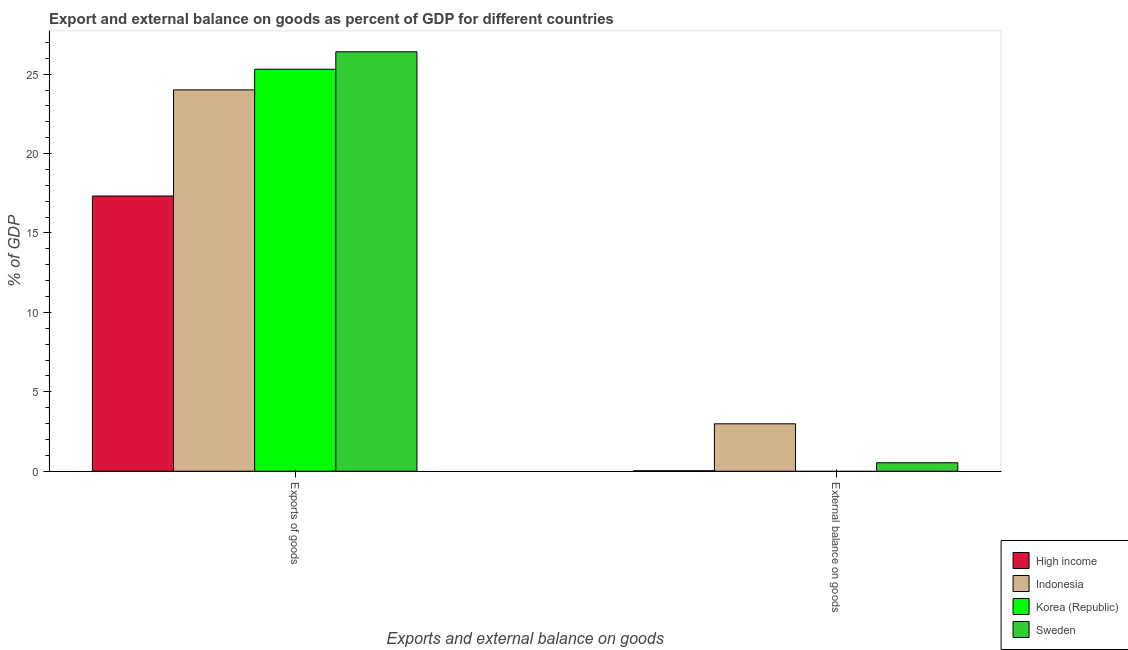Are the number of bars per tick equal to the number of legend labels?
Your response must be concise. No. Are the number of bars on each tick of the X-axis equal?
Your response must be concise. No. How many bars are there on the 1st tick from the left?
Your response must be concise. 4. What is the label of the 2nd group of bars from the left?
Provide a short and direct response. External balance on goods. What is the export of goods as percentage of gdp in Sweden?
Your answer should be compact. 26.41. Across all countries, what is the maximum external balance on goods as percentage of gdp?
Offer a terse response. 2.99. Across all countries, what is the minimum export of goods as percentage of gdp?
Keep it short and to the point. 17.33. What is the total external balance on goods as percentage of gdp in the graph?
Your answer should be very brief. 3.55. What is the difference between the export of goods as percentage of gdp in Korea (Republic) and that in Sweden?
Provide a succinct answer. -1.1. What is the difference between the external balance on goods as percentage of gdp in Sweden and the export of goods as percentage of gdp in High income?
Your answer should be very brief. -16.79. What is the average export of goods as percentage of gdp per country?
Ensure brevity in your answer.  23.26. What is the difference between the external balance on goods as percentage of gdp and export of goods as percentage of gdp in Indonesia?
Keep it short and to the point. -21.02. What is the ratio of the export of goods as percentage of gdp in Korea (Republic) to that in High income?
Your response must be concise. 1.46. In how many countries, is the external balance on goods as percentage of gdp greater than the average external balance on goods as percentage of gdp taken over all countries?
Your answer should be very brief. 1. How many bars are there?
Your answer should be compact. 7. What is the difference between two consecutive major ticks on the Y-axis?
Your answer should be compact. 5. Are the values on the major ticks of Y-axis written in scientific E-notation?
Your answer should be compact. No. Does the graph contain grids?
Provide a short and direct response. No. Where does the legend appear in the graph?
Offer a very short reply. Bottom right. How are the legend labels stacked?
Give a very brief answer. Vertical. What is the title of the graph?
Give a very brief answer. Export and external balance on goods as percent of GDP for different countries. Does "Macedonia" appear as one of the legend labels in the graph?
Your response must be concise. No. What is the label or title of the X-axis?
Provide a succinct answer. Exports and external balance on goods. What is the label or title of the Y-axis?
Ensure brevity in your answer.  % of GDP. What is the % of GDP of High income in Exports of goods?
Offer a very short reply. 17.33. What is the % of GDP in Indonesia in Exports of goods?
Your answer should be compact. 24.01. What is the % of GDP of Korea (Republic) in Exports of goods?
Ensure brevity in your answer.  25.31. What is the % of GDP in Sweden in Exports of goods?
Offer a very short reply. 26.41. What is the % of GDP of High income in External balance on goods?
Your answer should be very brief. 0.03. What is the % of GDP in Indonesia in External balance on goods?
Keep it short and to the point. 2.99. What is the % of GDP of Korea (Republic) in External balance on goods?
Offer a terse response. 0. What is the % of GDP in Sweden in External balance on goods?
Keep it short and to the point. 0.53. Across all Exports and external balance on goods, what is the maximum % of GDP in High income?
Ensure brevity in your answer.  17.33. Across all Exports and external balance on goods, what is the maximum % of GDP in Indonesia?
Ensure brevity in your answer.  24.01. Across all Exports and external balance on goods, what is the maximum % of GDP of Korea (Republic)?
Give a very brief answer. 25.31. Across all Exports and external balance on goods, what is the maximum % of GDP in Sweden?
Keep it short and to the point. 26.41. Across all Exports and external balance on goods, what is the minimum % of GDP in High income?
Provide a short and direct response. 0.03. Across all Exports and external balance on goods, what is the minimum % of GDP of Indonesia?
Offer a terse response. 2.99. Across all Exports and external balance on goods, what is the minimum % of GDP in Sweden?
Give a very brief answer. 0.53. What is the total % of GDP of High income in the graph?
Your response must be concise. 17.36. What is the total % of GDP of Indonesia in the graph?
Your response must be concise. 26.99. What is the total % of GDP of Korea (Republic) in the graph?
Offer a very short reply. 25.31. What is the total % of GDP of Sweden in the graph?
Your answer should be very brief. 26.94. What is the difference between the % of GDP of High income in Exports of goods and that in External balance on goods?
Provide a succinct answer. 17.3. What is the difference between the % of GDP in Indonesia in Exports of goods and that in External balance on goods?
Offer a very short reply. 21.02. What is the difference between the % of GDP of Sweden in Exports of goods and that in External balance on goods?
Provide a succinct answer. 25.87. What is the difference between the % of GDP in High income in Exports of goods and the % of GDP in Indonesia in External balance on goods?
Make the answer very short. 14.34. What is the difference between the % of GDP in High income in Exports of goods and the % of GDP in Sweden in External balance on goods?
Give a very brief answer. 16.79. What is the difference between the % of GDP in Indonesia in Exports of goods and the % of GDP in Sweden in External balance on goods?
Ensure brevity in your answer.  23.48. What is the difference between the % of GDP of Korea (Republic) in Exports of goods and the % of GDP of Sweden in External balance on goods?
Offer a very short reply. 24.77. What is the average % of GDP in High income per Exports and external balance on goods?
Give a very brief answer. 8.68. What is the average % of GDP of Indonesia per Exports and external balance on goods?
Give a very brief answer. 13.5. What is the average % of GDP of Korea (Republic) per Exports and external balance on goods?
Your answer should be compact. 12.65. What is the average % of GDP in Sweden per Exports and external balance on goods?
Keep it short and to the point. 13.47. What is the difference between the % of GDP of High income and % of GDP of Indonesia in Exports of goods?
Your answer should be compact. -6.68. What is the difference between the % of GDP in High income and % of GDP in Korea (Republic) in Exports of goods?
Make the answer very short. -7.98. What is the difference between the % of GDP in High income and % of GDP in Sweden in Exports of goods?
Provide a short and direct response. -9.08. What is the difference between the % of GDP of Indonesia and % of GDP of Korea (Republic) in Exports of goods?
Make the answer very short. -1.3. What is the difference between the % of GDP in Indonesia and % of GDP in Sweden in Exports of goods?
Make the answer very short. -2.4. What is the difference between the % of GDP in Korea (Republic) and % of GDP in Sweden in Exports of goods?
Offer a very short reply. -1.1. What is the difference between the % of GDP of High income and % of GDP of Indonesia in External balance on goods?
Your response must be concise. -2.96. What is the difference between the % of GDP in High income and % of GDP in Sweden in External balance on goods?
Your response must be concise. -0.5. What is the difference between the % of GDP in Indonesia and % of GDP in Sweden in External balance on goods?
Provide a short and direct response. 2.45. What is the ratio of the % of GDP in High income in Exports of goods to that in External balance on goods?
Give a very brief answer. 617.35. What is the ratio of the % of GDP in Indonesia in Exports of goods to that in External balance on goods?
Your answer should be compact. 8.04. What is the ratio of the % of GDP of Sweden in Exports of goods to that in External balance on goods?
Your response must be concise. 49.55. What is the difference between the highest and the second highest % of GDP of High income?
Ensure brevity in your answer.  17.3. What is the difference between the highest and the second highest % of GDP in Indonesia?
Provide a succinct answer. 21.02. What is the difference between the highest and the second highest % of GDP in Sweden?
Your answer should be very brief. 25.87. What is the difference between the highest and the lowest % of GDP of High income?
Offer a terse response. 17.3. What is the difference between the highest and the lowest % of GDP of Indonesia?
Offer a terse response. 21.02. What is the difference between the highest and the lowest % of GDP of Korea (Republic)?
Ensure brevity in your answer.  25.31. What is the difference between the highest and the lowest % of GDP in Sweden?
Keep it short and to the point. 25.87. 